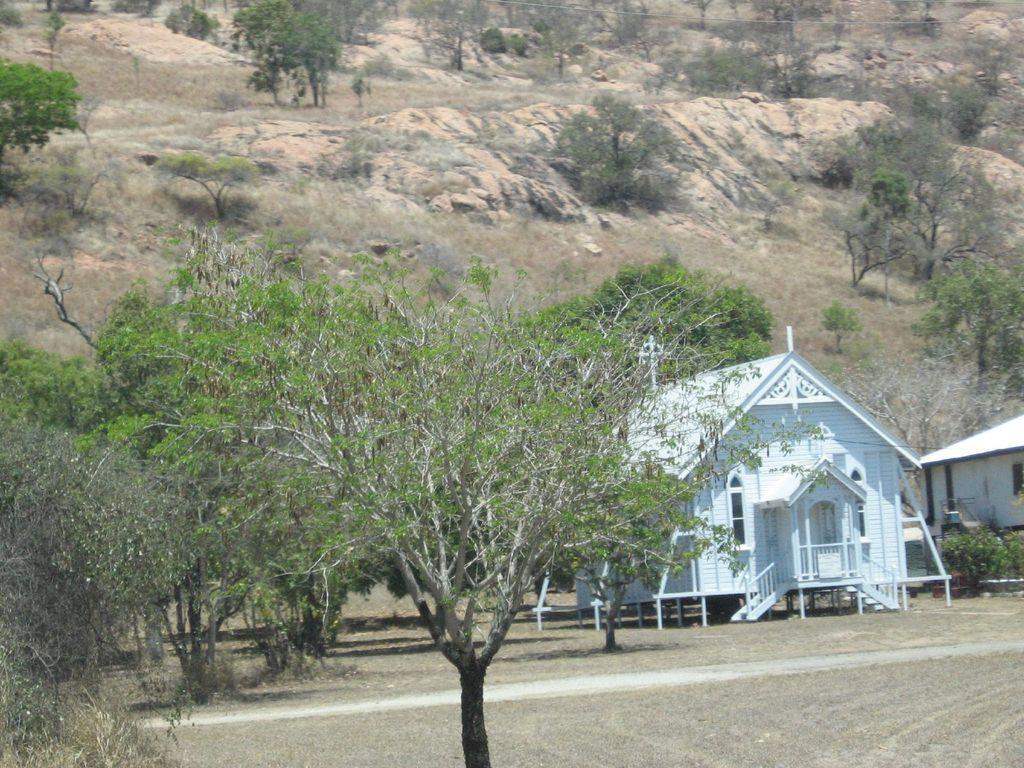What can be seen at the base of the image? The ground is visible in the image. What type of structures are present in the image? There are houses in the image. What type of vegetation is present in the image? Plants and trees are visible in the image. What else can be seen in the image besides houses and vegetation? There are objects in the image. What can be seen in the background of the image? Rocks are present in the background of the image. What type of soup is being served in the image? There is no soup present in the image. What type of wood is used to construct the houses in the image? The image does not provide information about the type of wood used to construct the houses. 